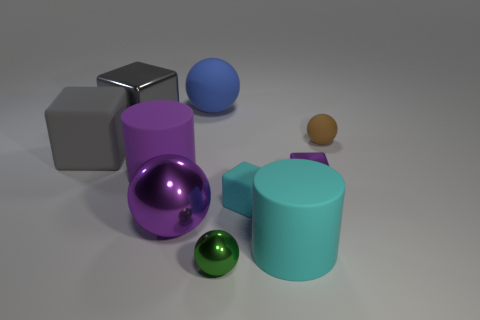Subtract all cyan balls. Subtract all brown cylinders. How many balls are left? 4 Subtract all blocks. How many objects are left? 6 Add 3 small green spheres. How many small green spheres exist? 4 Subtract 0 gray cylinders. How many objects are left? 10 Subtract all shiny balls. Subtract all blue rubber spheres. How many objects are left? 7 Add 1 balls. How many balls are left? 5 